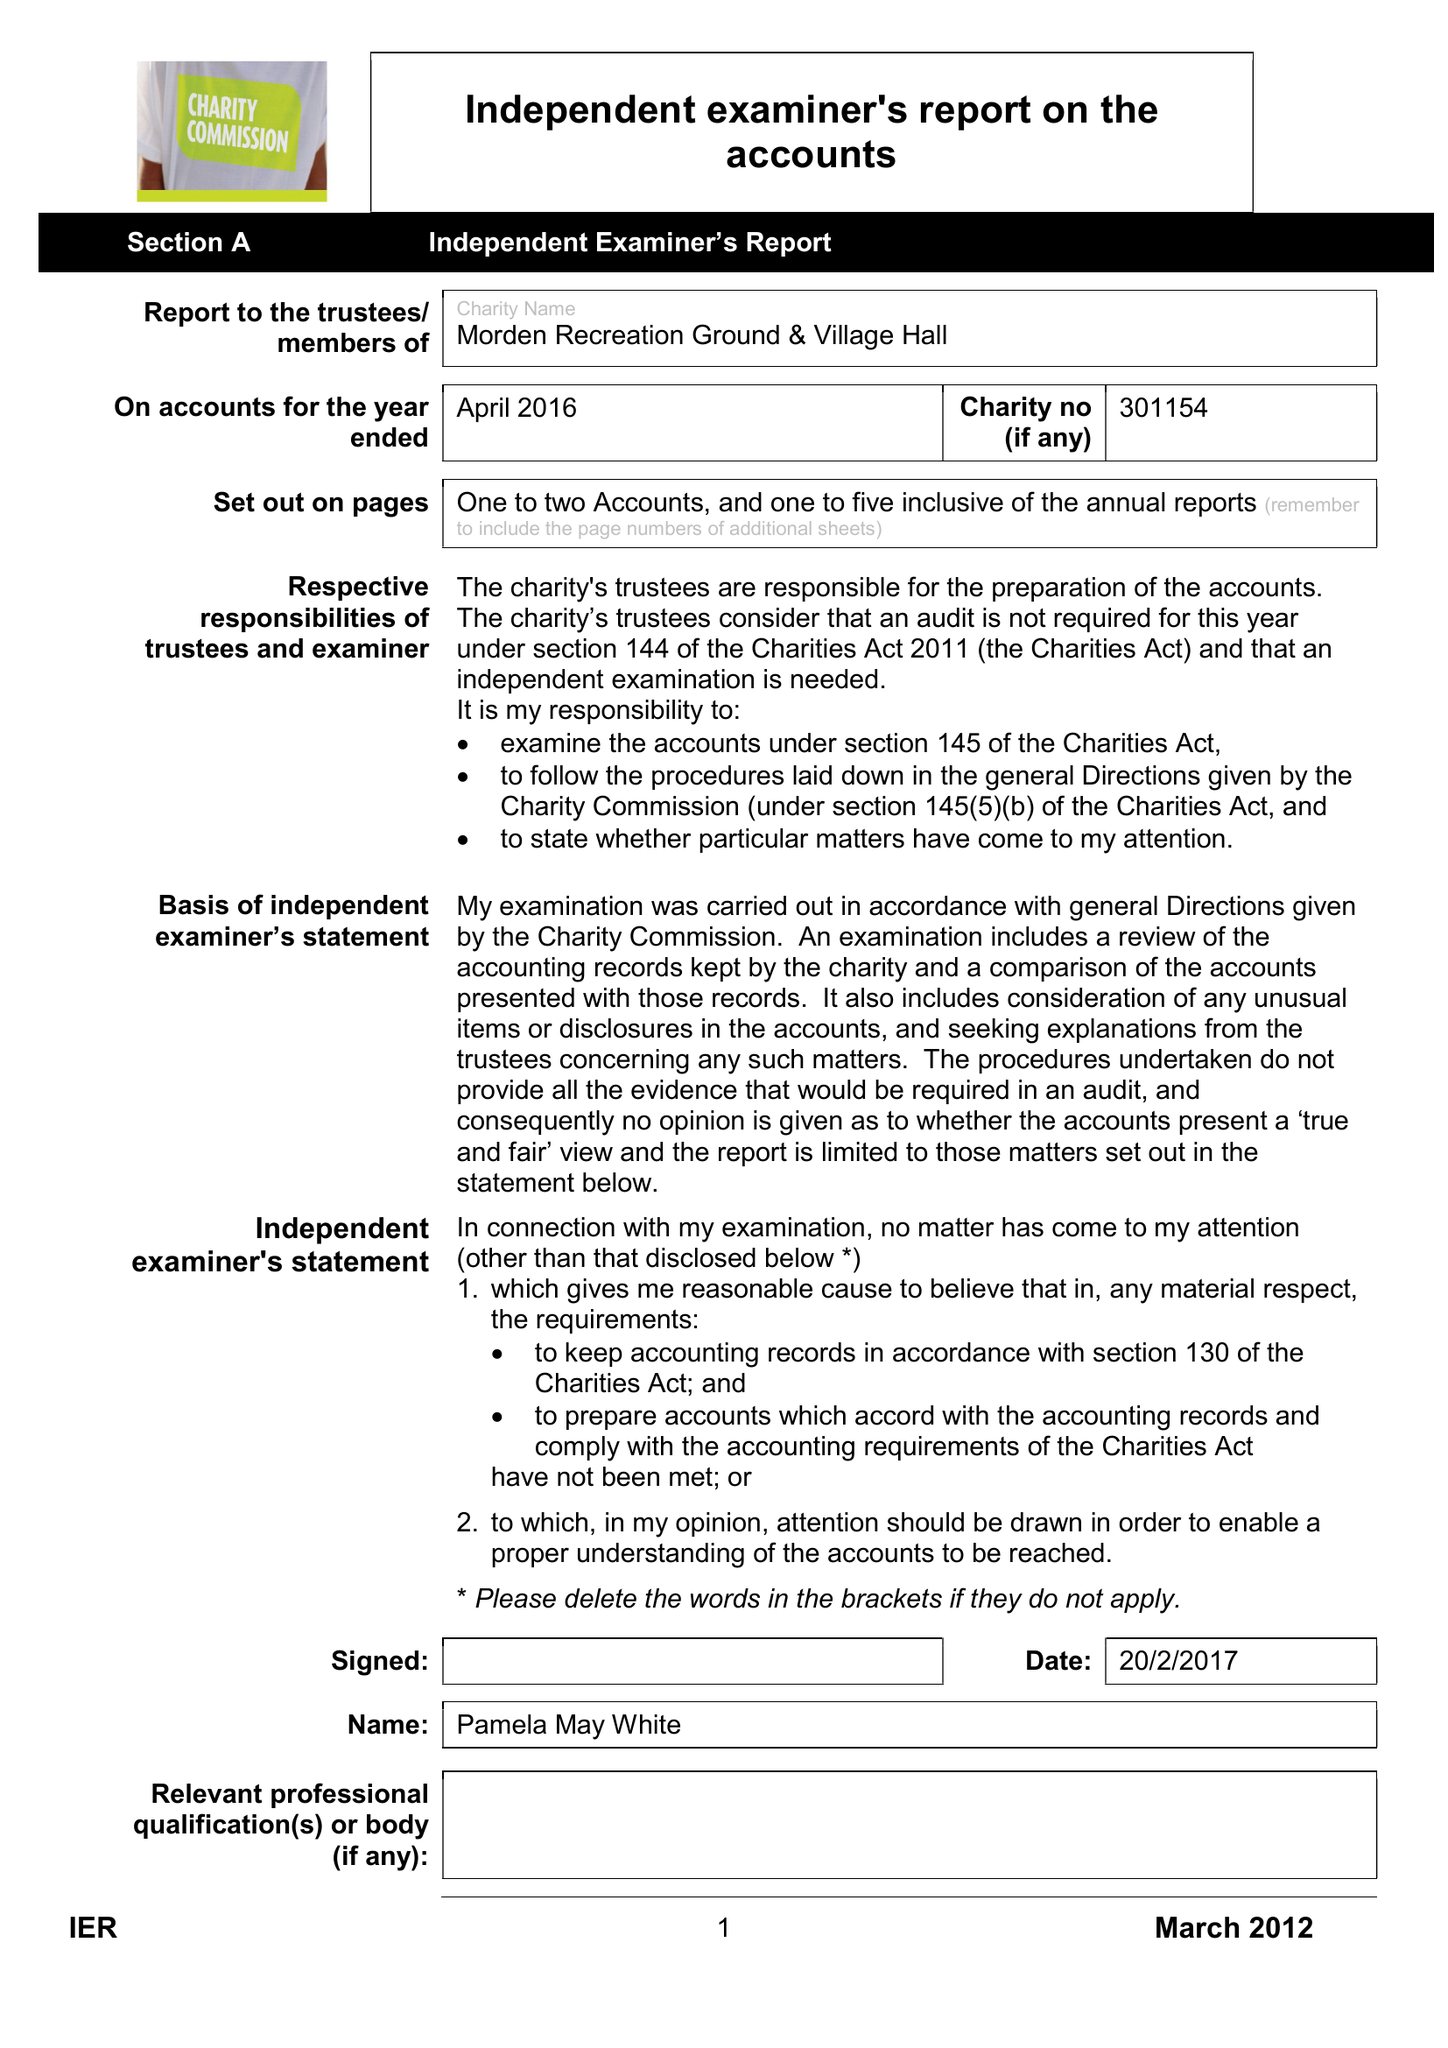What is the value for the report_date?
Answer the question using a single word or phrase. 2016-04-30 